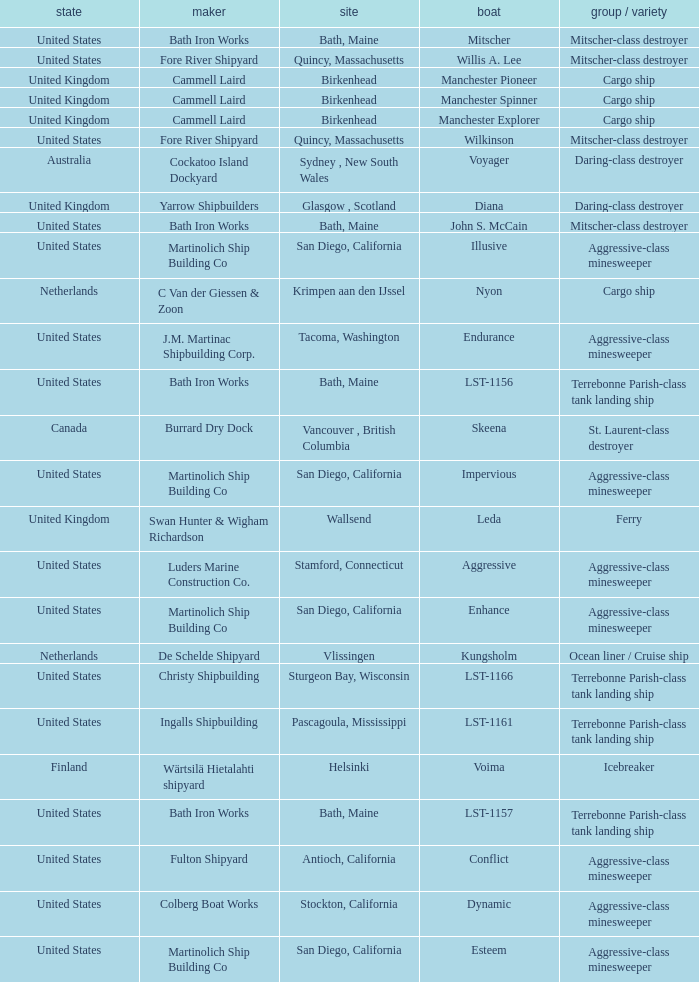What is the Cargo Ship located at Birkenhead? Manchester Pioneer, Manchester Spinner, Manchester Explorer. 